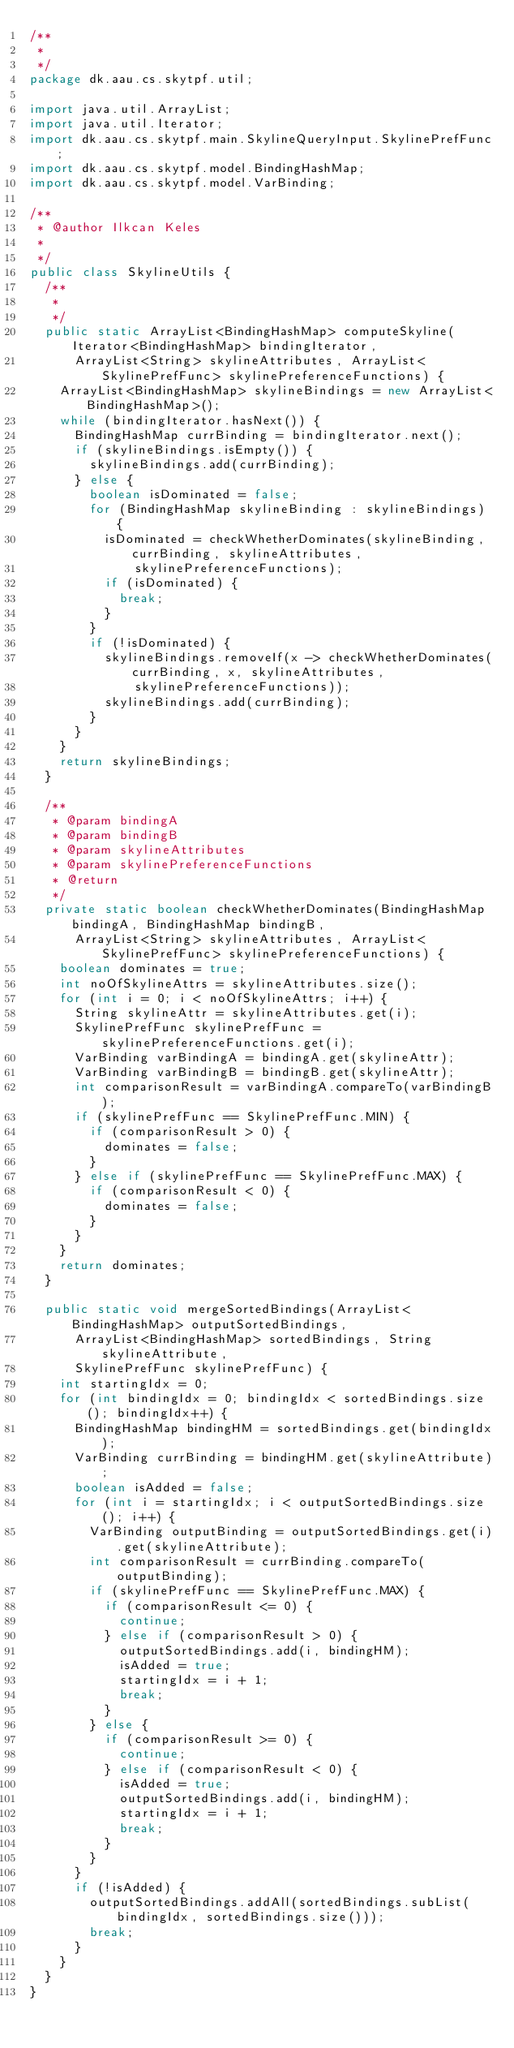Convert code to text. <code><loc_0><loc_0><loc_500><loc_500><_Java_>/**
 * 
 */
package dk.aau.cs.skytpf.util;

import java.util.ArrayList;
import java.util.Iterator;
import dk.aau.cs.skytpf.main.SkylineQueryInput.SkylinePrefFunc;
import dk.aau.cs.skytpf.model.BindingHashMap;
import dk.aau.cs.skytpf.model.VarBinding;

/**
 * @author Ilkcan Keles
 *
 */
public class SkylineUtils {
  /**
   * 
   */
  public static ArrayList<BindingHashMap> computeSkyline(Iterator<BindingHashMap> bindingIterator,
      ArrayList<String> skylineAttributes, ArrayList<SkylinePrefFunc> skylinePreferenceFunctions) {
    ArrayList<BindingHashMap> skylineBindings = new ArrayList<BindingHashMap>();
    while (bindingIterator.hasNext()) {
      BindingHashMap currBinding = bindingIterator.next();
      if (skylineBindings.isEmpty()) {
        skylineBindings.add(currBinding);
      } else {
        boolean isDominated = false;
        for (BindingHashMap skylineBinding : skylineBindings) {
          isDominated = checkWhetherDominates(skylineBinding, currBinding, skylineAttributes,
              skylinePreferenceFunctions);
          if (isDominated) {
            break;
          }
        }
        if (!isDominated) {
          skylineBindings.removeIf(x -> checkWhetherDominates(currBinding, x, skylineAttributes,
              skylinePreferenceFunctions));
          skylineBindings.add(currBinding);
        }
      }
    }
    return skylineBindings;
  }

  /**
   * @param bindingA
   * @param bindingB
   * @param skylineAttributes
   * @param skylinePreferenceFunctions
   * @return
   */
  private static boolean checkWhetherDominates(BindingHashMap bindingA, BindingHashMap bindingB,
      ArrayList<String> skylineAttributes, ArrayList<SkylinePrefFunc> skylinePreferenceFunctions) {
    boolean dominates = true;
    int noOfSkylineAttrs = skylineAttributes.size();
    for (int i = 0; i < noOfSkylineAttrs; i++) {
      String skylineAttr = skylineAttributes.get(i);
      SkylinePrefFunc skylinePrefFunc = skylinePreferenceFunctions.get(i);
      VarBinding varBindingA = bindingA.get(skylineAttr);
      VarBinding varBindingB = bindingB.get(skylineAttr);
      int comparisonResult = varBindingA.compareTo(varBindingB);
      if (skylinePrefFunc == SkylinePrefFunc.MIN) {
        if (comparisonResult > 0) {
          dominates = false;
        }
      } else if (skylinePrefFunc == SkylinePrefFunc.MAX) {
        if (comparisonResult < 0) {
          dominates = false;
        }
      }
    }
    return dominates;
  }

  public static void mergeSortedBindings(ArrayList<BindingHashMap> outputSortedBindings,
      ArrayList<BindingHashMap> sortedBindings, String skylineAttribute,
      SkylinePrefFunc skylinePrefFunc) {
    int startingIdx = 0;
    for (int bindingIdx = 0; bindingIdx < sortedBindings.size(); bindingIdx++) {
      BindingHashMap bindingHM = sortedBindings.get(bindingIdx);
      VarBinding currBinding = bindingHM.get(skylineAttribute);
      boolean isAdded = false;
      for (int i = startingIdx; i < outputSortedBindings.size(); i++) {
        VarBinding outputBinding = outputSortedBindings.get(i).get(skylineAttribute);
        int comparisonResult = currBinding.compareTo(outputBinding);
        if (skylinePrefFunc == SkylinePrefFunc.MAX) {
          if (comparisonResult <= 0) {
            continue;
          } else if (comparisonResult > 0) {
            outputSortedBindings.add(i, bindingHM);
            isAdded = true;
            startingIdx = i + 1;
            break;
          }
        } else {
          if (comparisonResult >= 0) {
            continue;
          } else if (comparisonResult < 0) {
            isAdded = true;
            outputSortedBindings.add(i, bindingHM);
            startingIdx = i + 1;
            break;
          }
        }
      }
      if (!isAdded) {
        outputSortedBindings.addAll(sortedBindings.subList(bindingIdx, sortedBindings.size()));
        break;
      }
    }
  }
}
</code> 